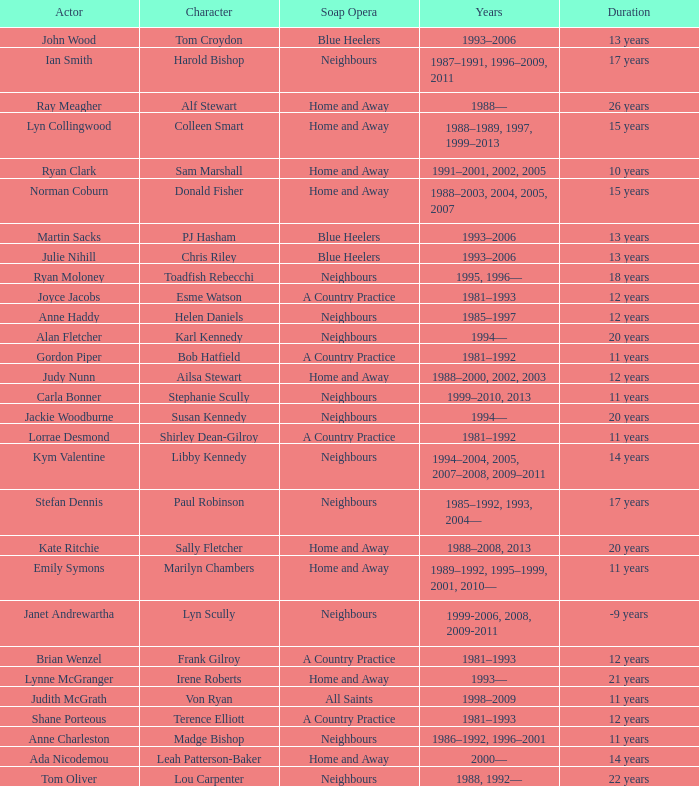Which years did Martin Sacks work on a soap opera? 1993–2006. 